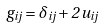Convert formula to latex. <formula><loc_0><loc_0><loc_500><loc_500>g _ { i j } = \delta _ { i j } + 2 \, u _ { i j }</formula> 